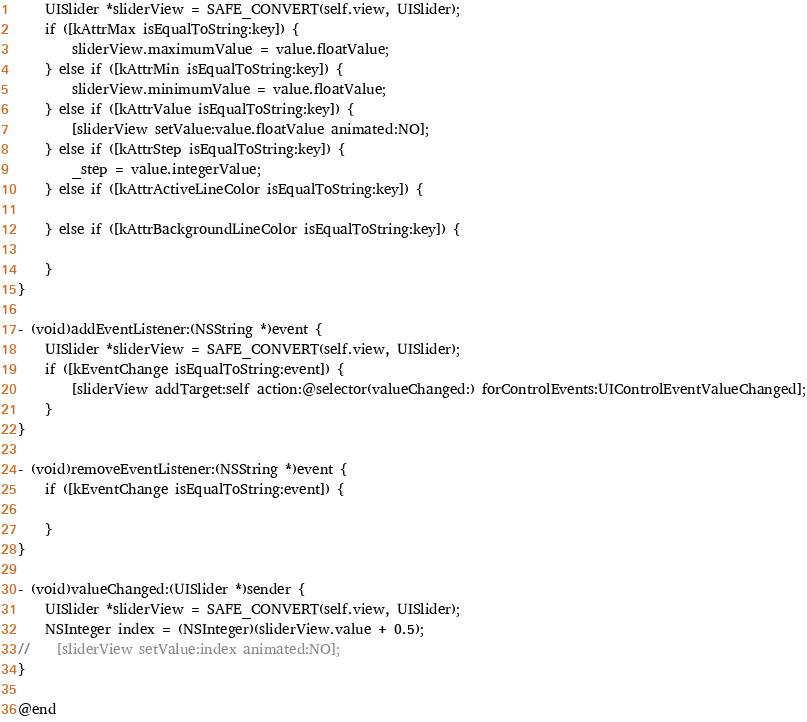Convert code to text. <code><loc_0><loc_0><loc_500><loc_500><_ObjectiveC_>    UISlider *sliderView = SAFE_CONVERT(self.view, UISlider);
    if ([kAttrMax isEqualToString:key]) {
        sliderView.maximumValue = value.floatValue;
    } else if ([kAttrMin isEqualToString:key]) {
        sliderView.minimumValue = value.floatValue;
    } else if ([kAttrValue isEqualToString:key]) {
        [sliderView setValue:value.floatValue animated:NO];
    } else if ([kAttrStep isEqualToString:key]) {
        _step = value.integerValue;
    } else if ([kAttrActiveLineColor isEqualToString:key]) {
        
    } else if ([kAttrBackgroundLineColor isEqualToString:key]) {
        
    }
}

- (void)addEventListener:(NSString *)event {
    UISlider *sliderView = SAFE_CONVERT(self.view, UISlider);
    if ([kEventChange isEqualToString:event]) {
        [sliderView addTarget:self action:@selector(valueChanged:) forControlEvents:UIControlEventValueChanged];
    }
}

- (void)removeEventListener:(NSString *)event {
    if ([kEventChange isEqualToString:event]) {
        
    }
}

- (void)valueChanged:(UISlider *)sender {
    UISlider *sliderView = SAFE_CONVERT(self.view, UISlider);
    NSInteger index = (NSInteger)(sliderView.value + 0.5);
//    [sliderView setValue:index animated:NO];
}

@end
</code> 